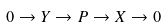<formula> <loc_0><loc_0><loc_500><loc_500>0 \to Y \to P \to X \to 0</formula> 